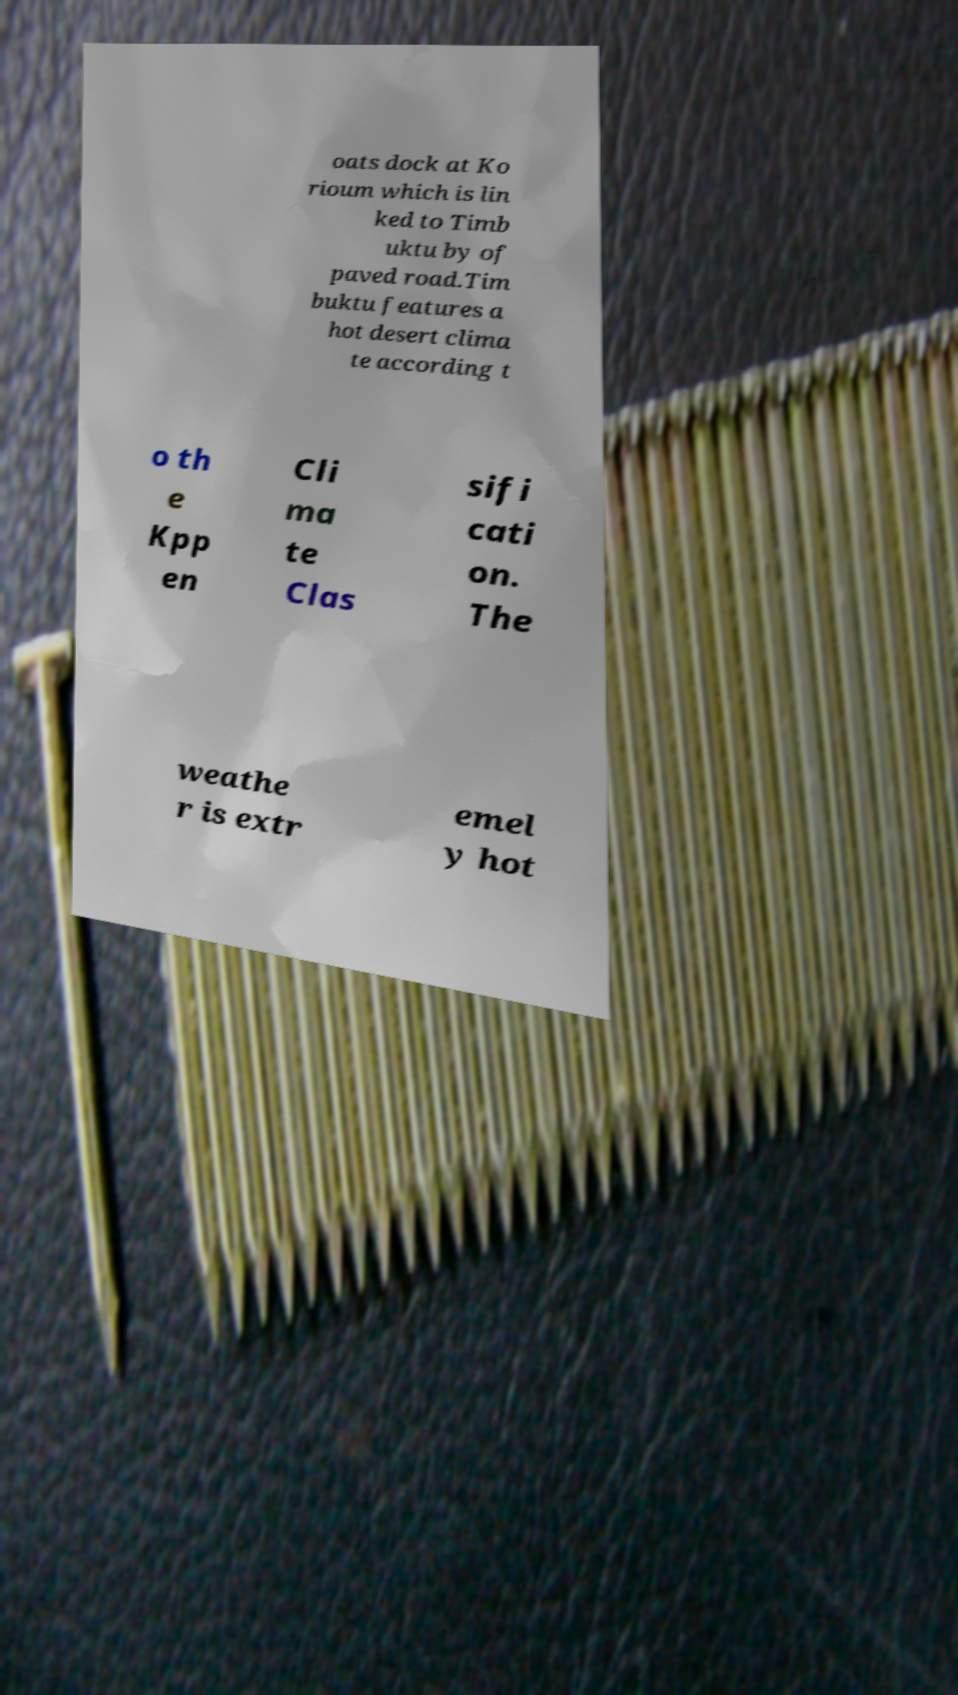Can you read and provide the text displayed in the image?This photo seems to have some interesting text. Can you extract and type it out for me? oats dock at Ko rioum which is lin ked to Timb uktu by of paved road.Tim buktu features a hot desert clima te according t o th e Kpp en Cli ma te Clas sifi cati on. The weathe r is extr emel y hot 